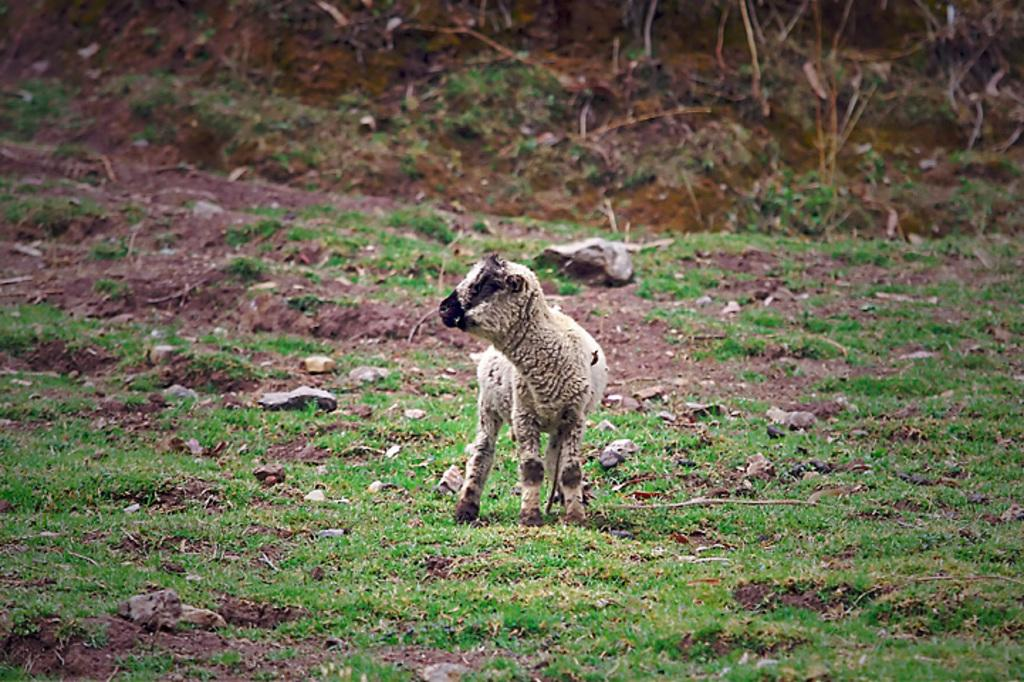What animal is present in the image? There is a sheep in the image. What is the sheep doing in the image? The sheep is standing on the ground. What type of surface is the sheep standing on? The ground is covered with grass. What type of arch can be seen in the image? There is no arch present in the image; it features a sheep standing on grass. What government-related activity is taking place in the image? There is no government-related activity present in the image; it features a sheep standing on grass. 